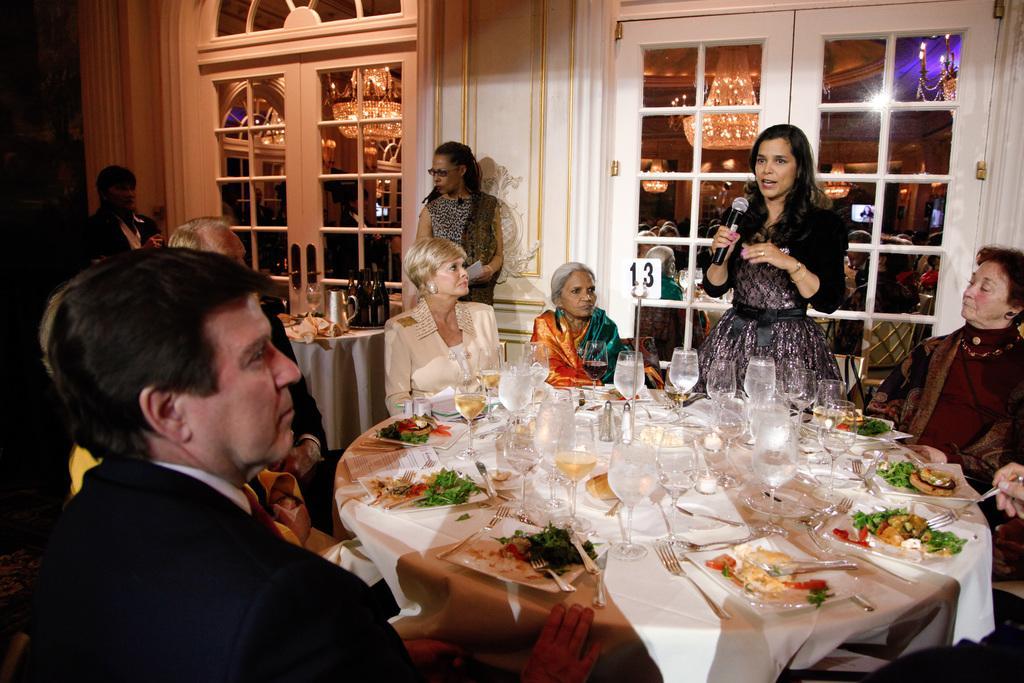Describe this image in one or two sentences. There are few people sitting on the chair at the table and a woman is standing and talking on mic. There are glasses,food items,plates,spoon,fork,knife on the table. On the left there are two persons standing at the table. In the background we can see door. Through window doors we can see chandelier and lights. 